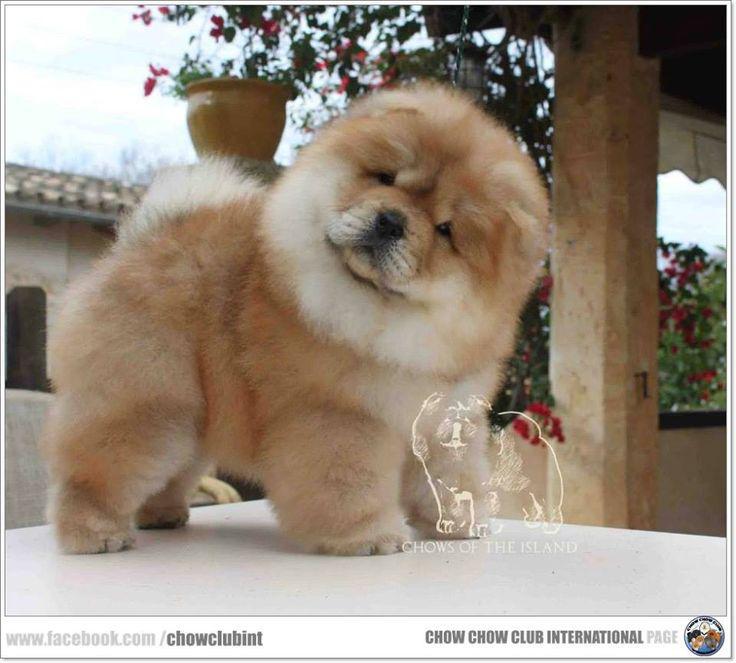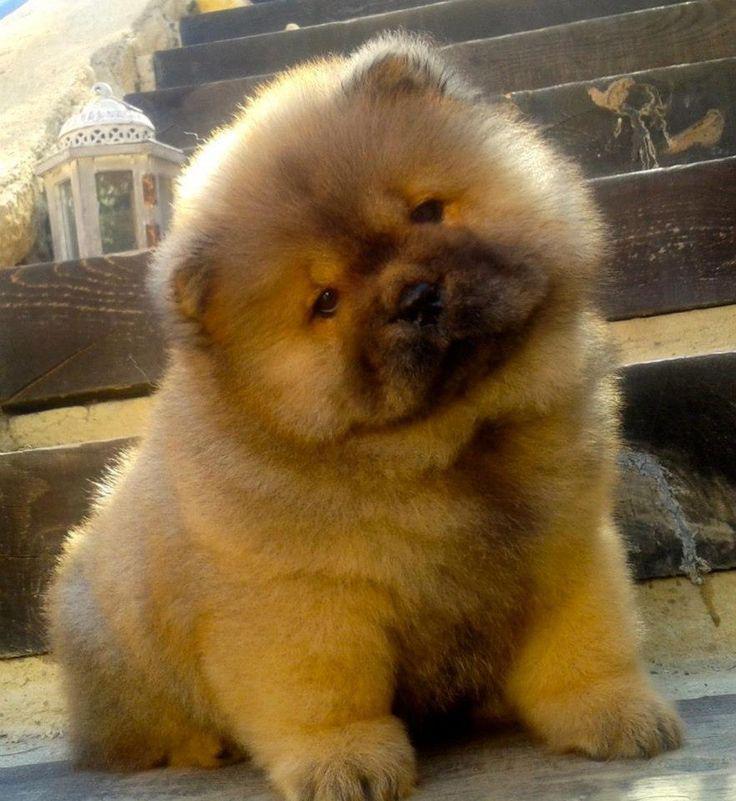The first image is the image on the left, the second image is the image on the right. Assess this claim about the two images: "An image shows at least one chow dog in a basket-like container.". Correct or not? Answer yes or no. No. The first image is the image on the left, the second image is the image on the right. Given the left and right images, does the statement "There is at least one human in one of the images." hold true? Answer yes or no. No. The first image is the image on the left, the second image is the image on the right. Considering the images on both sides, is "There is one human head in the image on the left." valid? Answer yes or no. No. 